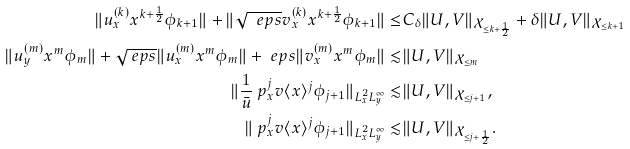Convert formula to latex. <formula><loc_0><loc_0><loc_500><loc_500>\| u ^ { ( k ) } _ { x } x ^ { k + \frac { 1 } { 2 } } \phi _ { k + 1 } \| + \| \sqrt { \ e p s } v ^ { ( k ) } _ { x } x ^ { k + \frac { 1 } { 2 } } \phi _ { k + 1 } \| \leq & C _ { \delta } \| U , V \| _ { \mathcal { X } _ { \leq k + \frac { 1 } { 2 } } } + \delta \| U , V \| _ { \mathcal { X } _ { \leq k + 1 } } \\ \| u ^ { ( m ) } _ { y } x ^ { m } \phi _ { m } \| + \sqrt { \ e p s } \| u ^ { ( m ) } _ { x } x ^ { m } \phi _ { m } \| + \ e p s \| v ^ { ( m ) } _ { x } x ^ { m } \phi _ { m } \| \lesssim & \| U , V \| _ { \mathcal { X } _ { \leq m } } \\ \| \frac { 1 } { \bar { u } } \ p _ { x } ^ { j } v \langle x \rangle ^ { j } \phi _ { j + 1 } \| _ { L ^ { 2 } _ { x } L ^ { \infty } _ { y } } \lesssim & \| U , V \| _ { \mathcal { X } _ { \leq j + 1 } } , \\ \| \ p _ { x } ^ { j } v \langle x \rangle ^ { j } \phi _ { j + 1 } \| _ { L ^ { 2 } _ { x } L ^ { \infty } _ { y } } \lesssim & \| U , V \| _ { \mathcal { X } _ { \leq j + \frac { 1 } { 2 } } } .</formula> 